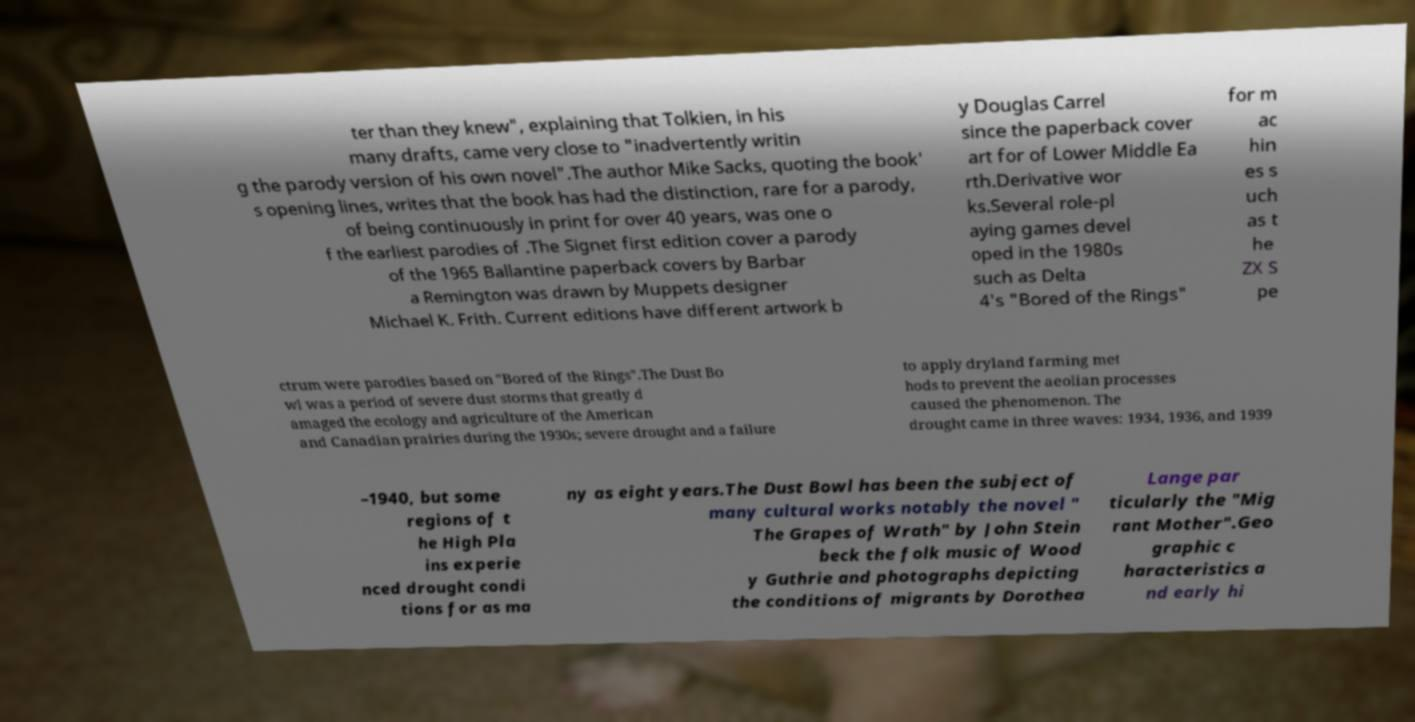Please read and relay the text visible in this image. What does it say? ter than they knew", explaining that Tolkien, in his many drafts, came very close to "inadvertently writin g the parody version of his own novel".The author Mike Sacks, quoting the book' s opening lines, writes that the book has had the distinction, rare for a parody, of being continuously in print for over 40 years, was one o f the earliest parodies of .The Signet first edition cover a parody of the 1965 Ballantine paperback covers by Barbar a Remington was drawn by Muppets designer Michael K. Frith. Current editions have different artwork b y Douglas Carrel since the paperback cover art for of Lower Middle Ea rth.Derivative wor ks.Several role-pl aying games devel oped in the 1980s such as Delta 4's "Bored of the Rings" for m ac hin es s uch as t he ZX S pe ctrum were parodies based on "Bored of the Rings".The Dust Bo wl was a period of severe dust storms that greatly d amaged the ecology and agriculture of the American and Canadian prairies during the 1930s; severe drought and a failure to apply dryland farming met hods to prevent the aeolian processes caused the phenomenon. The drought came in three waves: 1934, 1936, and 1939 –1940, but some regions of t he High Pla ins experie nced drought condi tions for as ma ny as eight years.The Dust Bowl has been the subject of many cultural works notably the novel " The Grapes of Wrath" by John Stein beck the folk music of Wood y Guthrie and photographs depicting the conditions of migrants by Dorothea Lange par ticularly the "Mig rant Mother".Geo graphic c haracteristics a nd early hi 